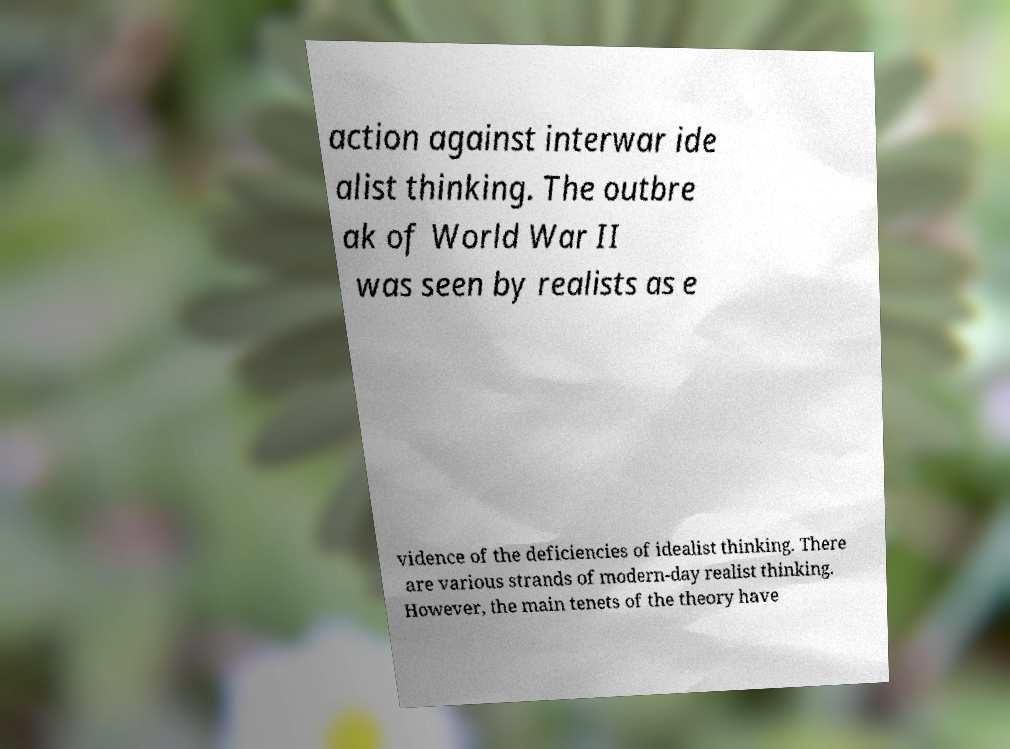Please identify and transcribe the text found in this image. action against interwar ide alist thinking. The outbre ak of World War II was seen by realists as e vidence of the deficiencies of idealist thinking. There are various strands of modern-day realist thinking. However, the main tenets of the theory have 